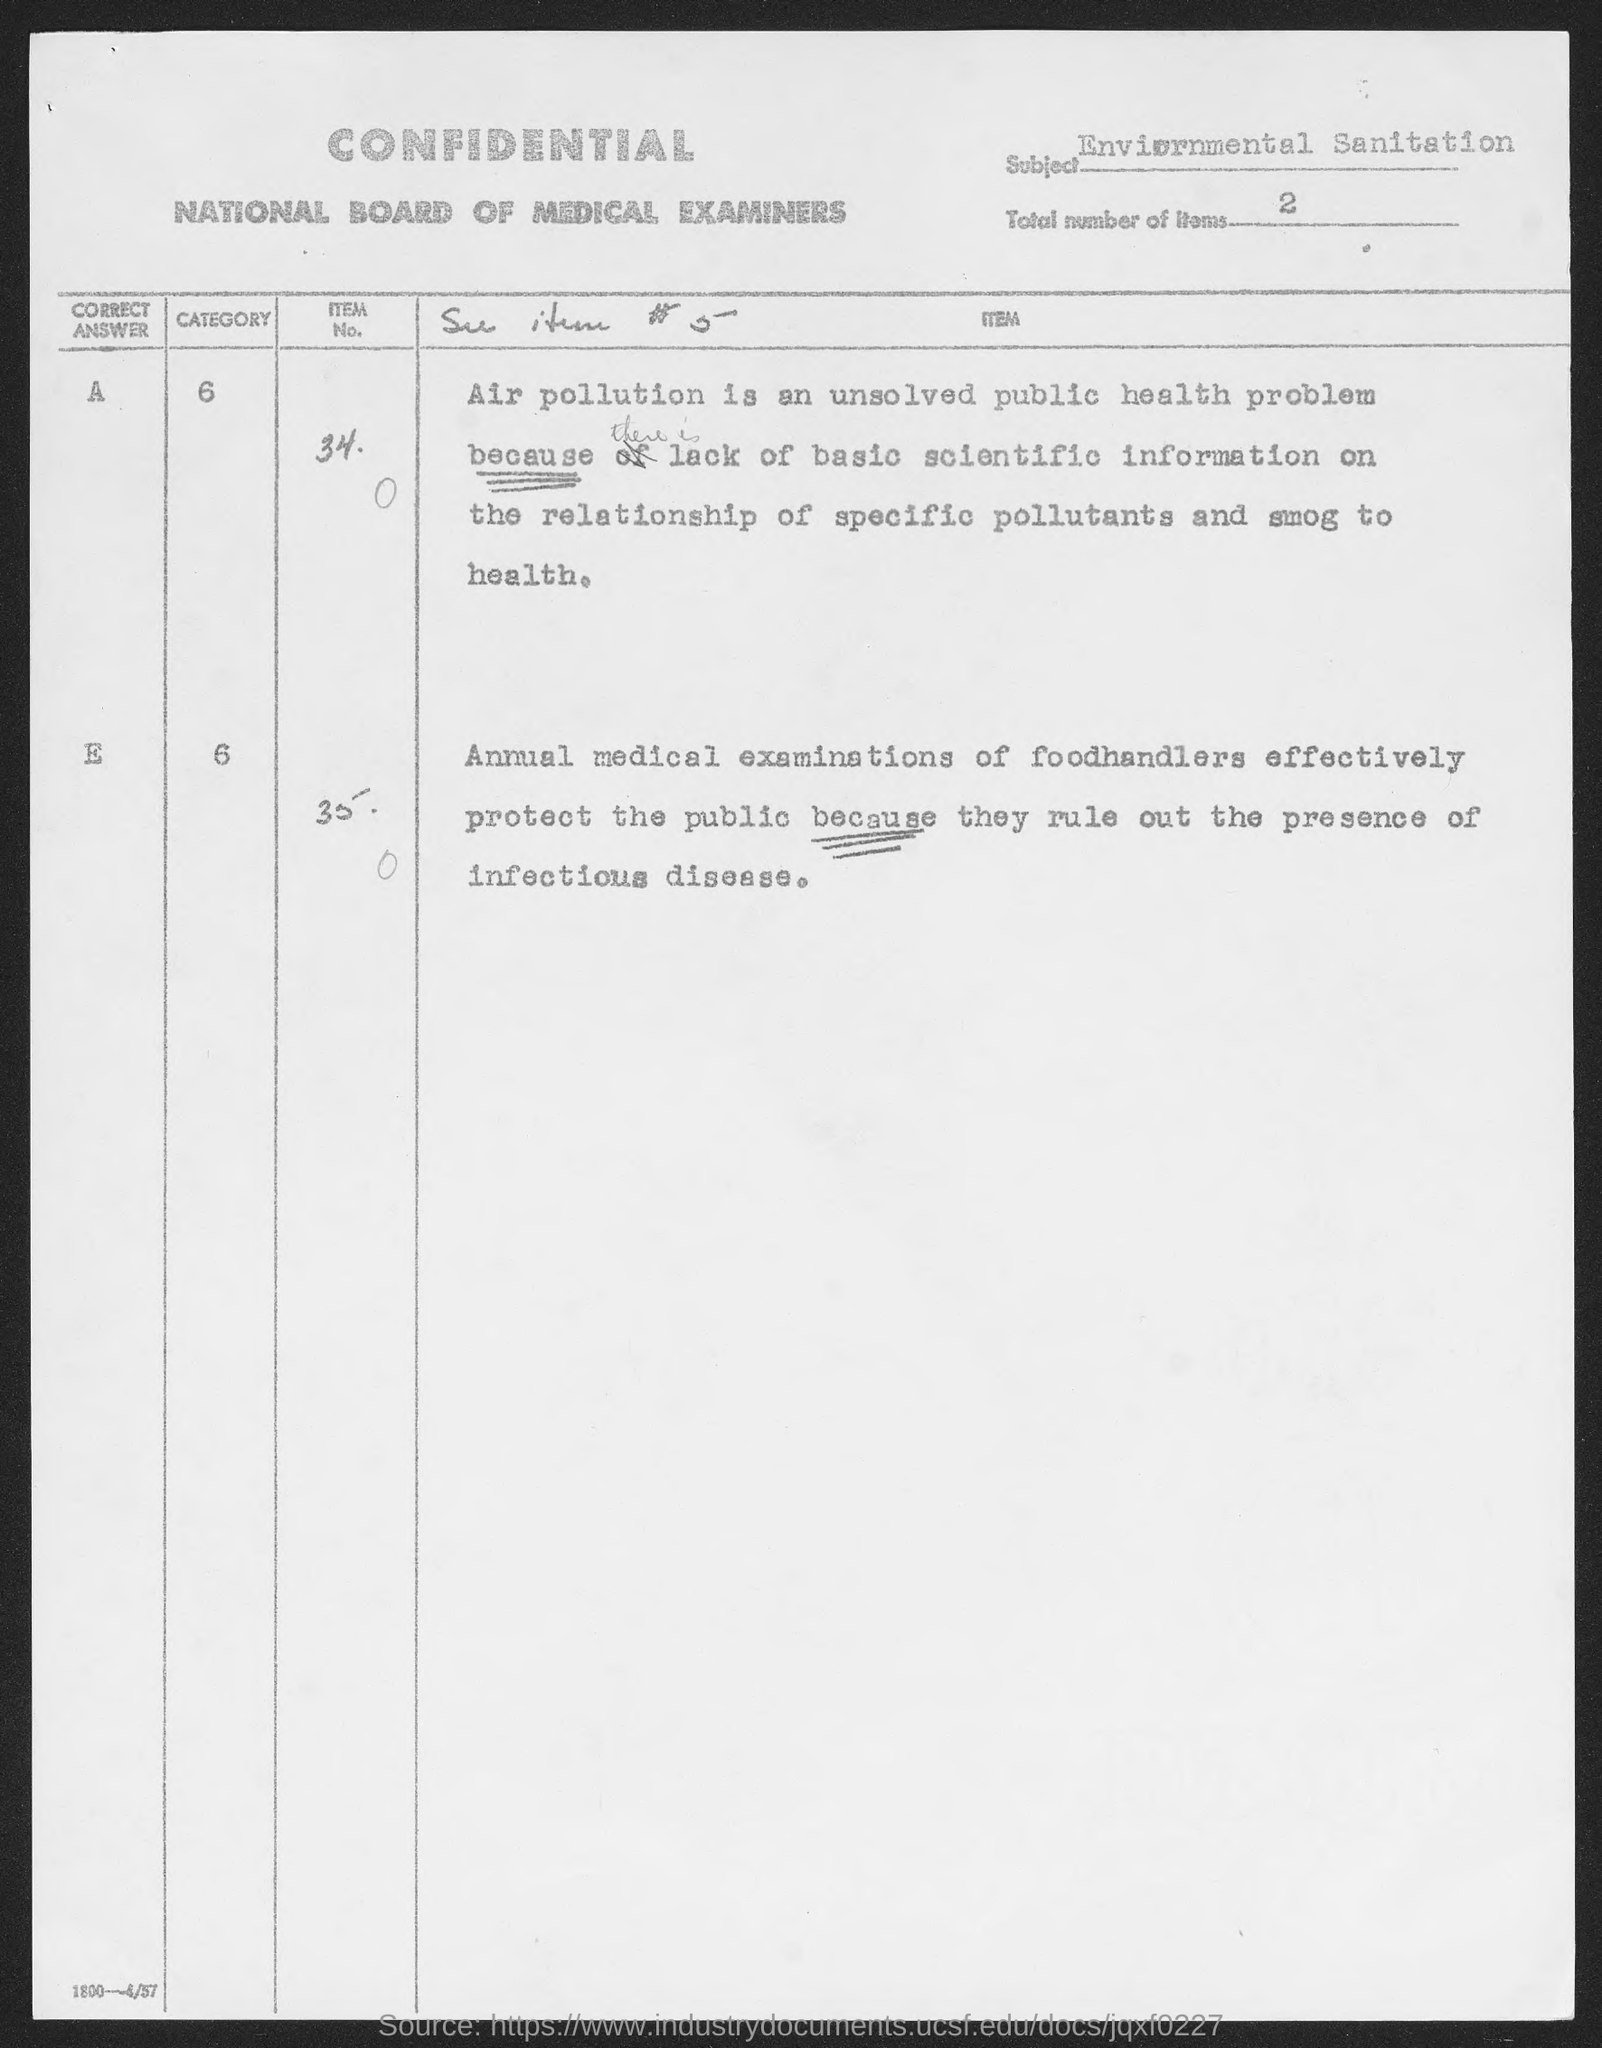Where is this form from?
Your answer should be very brief. NATIONAL BOARD OF MEDICAL EXAMINERS. What is the nature of the form?
Ensure brevity in your answer.  Confidential. 